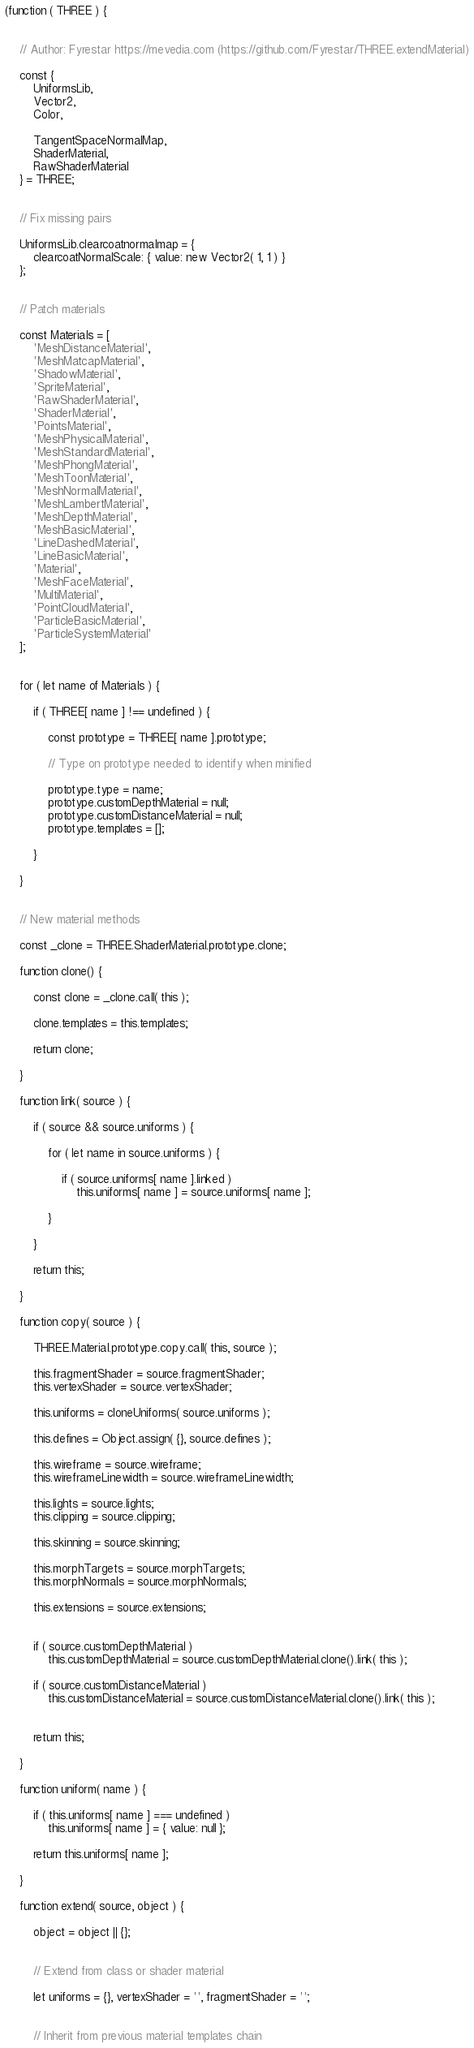Convert code to text. <code><loc_0><loc_0><loc_500><loc_500><_JavaScript_>(function ( THREE ) {


	// Author: Fyrestar https://mevedia.com (https://github.com/Fyrestar/THREE.extendMaterial)

	const {
		UniformsLib,
		Vector2,
		Color,

		TangentSpaceNormalMap,
		ShaderMaterial,
		RawShaderMaterial
	} = THREE;


	// Fix missing pairs

	UniformsLib.clearcoatnormalmap = {
		clearcoatNormalScale: { value: new Vector2( 1, 1 ) }
	};


	// Patch materials

	const Materials = [
		'MeshDistanceMaterial',
		'MeshMatcapMaterial',
		'ShadowMaterial',
		'SpriteMaterial',
		'RawShaderMaterial',
		'ShaderMaterial',
		'PointsMaterial',
		'MeshPhysicalMaterial',
		'MeshStandardMaterial',
		'MeshPhongMaterial',
		'MeshToonMaterial',
		'MeshNormalMaterial',
		'MeshLambertMaterial',
		'MeshDepthMaterial',
		'MeshBasicMaterial',
		'LineDashedMaterial',
		'LineBasicMaterial',
		'Material',
		'MeshFaceMaterial',
		'MultiMaterial',
		'PointCloudMaterial',
		'ParticleBasicMaterial',
		'ParticleSystemMaterial'
	];


	for ( let name of Materials ) {

		if ( THREE[ name ] !== undefined ) {

			const prototype = THREE[ name ].prototype;

			// Type on prototype needed to identify when minified

			prototype.type = name;
			prototype.customDepthMaterial = null;
			prototype.customDistanceMaterial = null;
			prototype.templates = [];

		}

	}


	// New material methods

	const _clone = THREE.ShaderMaterial.prototype.clone;

	function clone() {

		const clone = _clone.call( this );

		clone.templates = this.templates;

		return clone;

	}

	function link( source ) {

		if ( source && source.uniforms ) {

			for ( let name in source.uniforms ) {

				if ( source.uniforms[ name ].linked )
					this.uniforms[ name ] = source.uniforms[ name ];

			}

		}

		return this;

	}

	function copy( source ) {

		THREE.Material.prototype.copy.call( this, source );

		this.fragmentShader = source.fragmentShader;
		this.vertexShader = source.vertexShader;

		this.uniforms = cloneUniforms( source.uniforms );

		this.defines = Object.assign( {}, source.defines );

		this.wireframe = source.wireframe;
		this.wireframeLinewidth = source.wireframeLinewidth;

		this.lights = source.lights;
		this.clipping = source.clipping;

		this.skinning = source.skinning;

		this.morphTargets = source.morphTargets;
		this.morphNormals = source.morphNormals;

		this.extensions = source.extensions;


		if ( source.customDepthMaterial )
			this.customDepthMaterial = source.customDepthMaterial.clone().link( this );

		if ( source.customDistanceMaterial )
			this.customDistanceMaterial = source.customDistanceMaterial.clone().link( this );


		return this;

	}

	function uniform( name ) {

		if ( this.uniforms[ name ] === undefined )
			this.uniforms[ name ] = { value: null };

		return this.uniforms[ name ];

	}

	function extend( source, object ) {

		object = object || {};


		// Extend from class or shader material

		let uniforms = {}, vertexShader = '', fragmentShader = '';


		// Inherit from previous material templates chain
</code> 